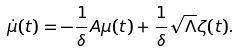<formula> <loc_0><loc_0><loc_500><loc_500>\dot { \mu } ( t ) = - \frac { 1 } { \delta } A \mu ( t ) + \frac { 1 } { \delta } \sqrt { \Lambda } \zeta ( t ) .</formula> 